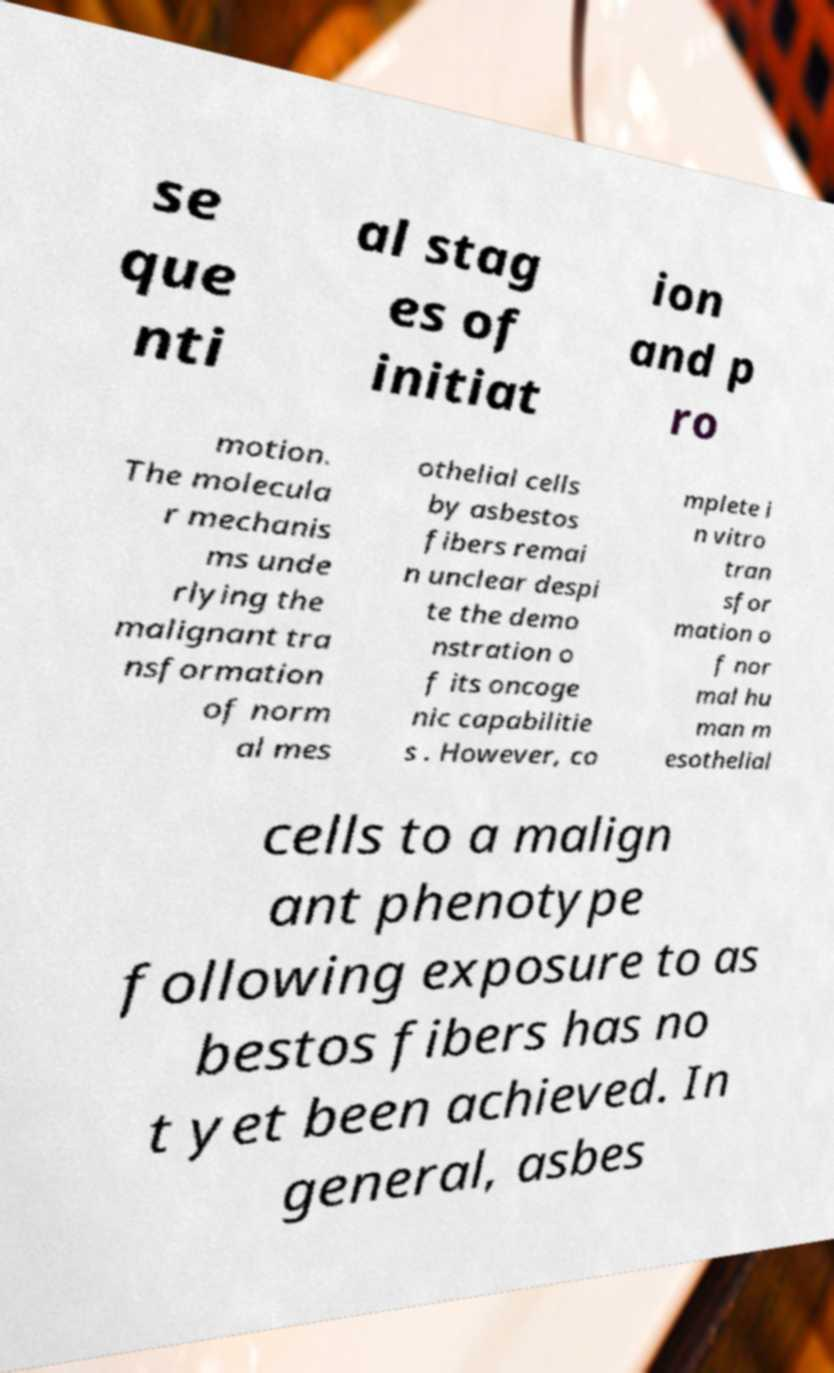Could you extract and type out the text from this image? se que nti al stag es of initiat ion and p ro motion. The molecula r mechanis ms unde rlying the malignant tra nsformation of norm al mes othelial cells by asbestos fibers remai n unclear despi te the demo nstration o f its oncoge nic capabilitie s . However, co mplete i n vitro tran sfor mation o f nor mal hu man m esothelial cells to a malign ant phenotype following exposure to as bestos fibers has no t yet been achieved. In general, asbes 